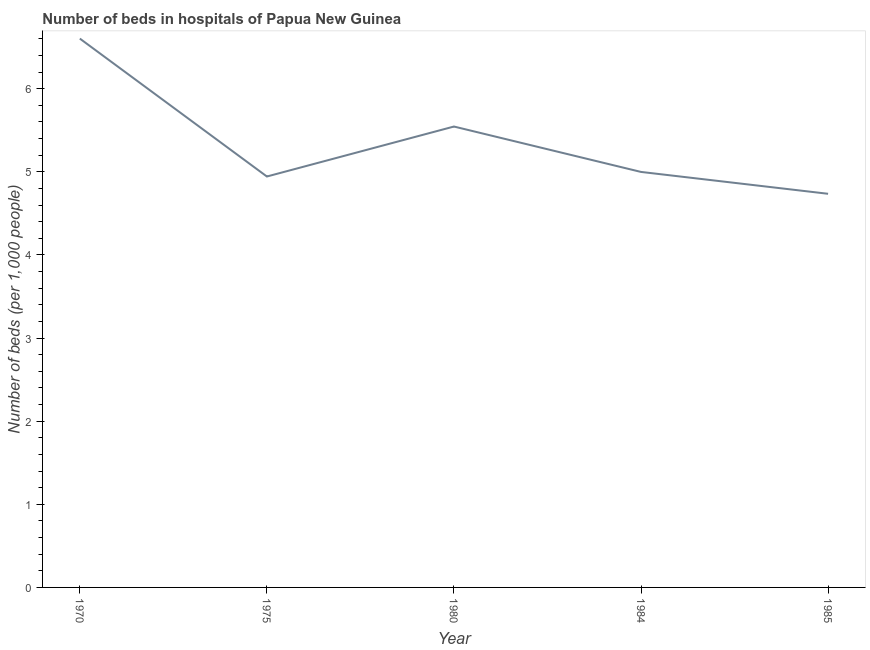What is the number of hospital beds in 1985?
Your answer should be very brief. 4.74. Across all years, what is the maximum number of hospital beds?
Offer a very short reply. 6.6. Across all years, what is the minimum number of hospital beds?
Your response must be concise. 4.74. In which year was the number of hospital beds maximum?
Your answer should be compact. 1970. What is the sum of the number of hospital beds?
Your response must be concise. 26.82. What is the difference between the number of hospital beds in 1984 and 1985?
Offer a very short reply. 0.26. What is the average number of hospital beds per year?
Make the answer very short. 5.36. What is the median number of hospital beds?
Make the answer very short. 5. What is the ratio of the number of hospital beds in 1984 to that in 1985?
Your answer should be compact. 1.06. What is the difference between the highest and the second highest number of hospital beds?
Your response must be concise. 1.06. Is the sum of the number of hospital beds in 1970 and 1985 greater than the maximum number of hospital beds across all years?
Your answer should be very brief. Yes. What is the difference between the highest and the lowest number of hospital beds?
Your answer should be compact. 1.87. How many lines are there?
Your answer should be very brief. 1. How many years are there in the graph?
Provide a short and direct response. 5. What is the difference between two consecutive major ticks on the Y-axis?
Provide a succinct answer. 1. Are the values on the major ticks of Y-axis written in scientific E-notation?
Your answer should be compact. No. Does the graph contain any zero values?
Your answer should be very brief. No. What is the title of the graph?
Keep it short and to the point. Number of beds in hospitals of Papua New Guinea. What is the label or title of the Y-axis?
Provide a short and direct response. Number of beds (per 1,0 people). What is the Number of beds (per 1,000 people) of 1970?
Offer a very short reply. 6.6. What is the Number of beds (per 1,000 people) in 1975?
Ensure brevity in your answer.  4.94. What is the Number of beds (per 1,000 people) of 1980?
Provide a succinct answer. 5.54. What is the Number of beds (per 1,000 people) of 1984?
Your response must be concise. 5. What is the Number of beds (per 1,000 people) of 1985?
Your answer should be very brief. 4.74. What is the difference between the Number of beds (per 1,000 people) in 1970 and 1975?
Offer a terse response. 1.66. What is the difference between the Number of beds (per 1,000 people) in 1970 and 1980?
Provide a succinct answer. 1.06. What is the difference between the Number of beds (per 1,000 people) in 1970 and 1984?
Offer a terse response. 1.6. What is the difference between the Number of beds (per 1,000 people) in 1970 and 1985?
Provide a succinct answer. 1.87. What is the difference between the Number of beds (per 1,000 people) in 1975 and 1980?
Provide a short and direct response. -0.6. What is the difference between the Number of beds (per 1,000 people) in 1975 and 1984?
Provide a short and direct response. -0.06. What is the difference between the Number of beds (per 1,000 people) in 1975 and 1985?
Ensure brevity in your answer.  0.21. What is the difference between the Number of beds (per 1,000 people) in 1980 and 1984?
Your answer should be very brief. 0.55. What is the difference between the Number of beds (per 1,000 people) in 1980 and 1985?
Provide a short and direct response. 0.81. What is the difference between the Number of beds (per 1,000 people) in 1984 and 1985?
Provide a succinct answer. 0.26. What is the ratio of the Number of beds (per 1,000 people) in 1970 to that in 1975?
Provide a short and direct response. 1.34. What is the ratio of the Number of beds (per 1,000 people) in 1970 to that in 1980?
Ensure brevity in your answer.  1.19. What is the ratio of the Number of beds (per 1,000 people) in 1970 to that in 1984?
Offer a very short reply. 1.32. What is the ratio of the Number of beds (per 1,000 people) in 1970 to that in 1985?
Keep it short and to the point. 1.39. What is the ratio of the Number of beds (per 1,000 people) in 1975 to that in 1980?
Provide a short and direct response. 0.89. What is the ratio of the Number of beds (per 1,000 people) in 1975 to that in 1984?
Provide a short and direct response. 0.99. What is the ratio of the Number of beds (per 1,000 people) in 1975 to that in 1985?
Give a very brief answer. 1.04. What is the ratio of the Number of beds (per 1,000 people) in 1980 to that in 1984?
Give a very brief answer. 1.11. What is the ratio of the Number of beds (per 1,000 people) in 1980 to that in 1985?
Provide a short and direct response. 1.17. What is the ratio of the Number of beds (per 1,000 people) in 1984 to that in 1985?
Keep it short and to the point. 1.06. 